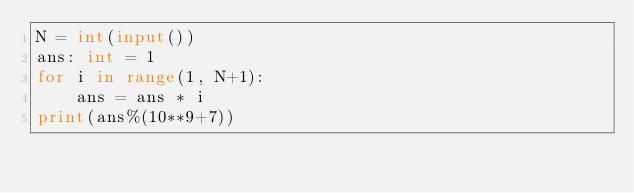<code> <loc_0><loc_0><loc_500><loc_500><_Python_>N = int(input())
ans: int = 1
for i in range(1, N+1):
    ans = ans * i
print(ans%(10**9+7))</code> 